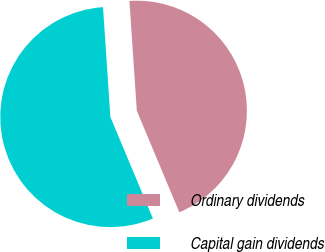<chart> <loc_0><loc_0><loc_500><loc_500><pie_chart><fcel>Ordinary dividends<fcel>Capital gain dividends<nl><fcel>44.75%<fcel>55.25%<nl></chart> 